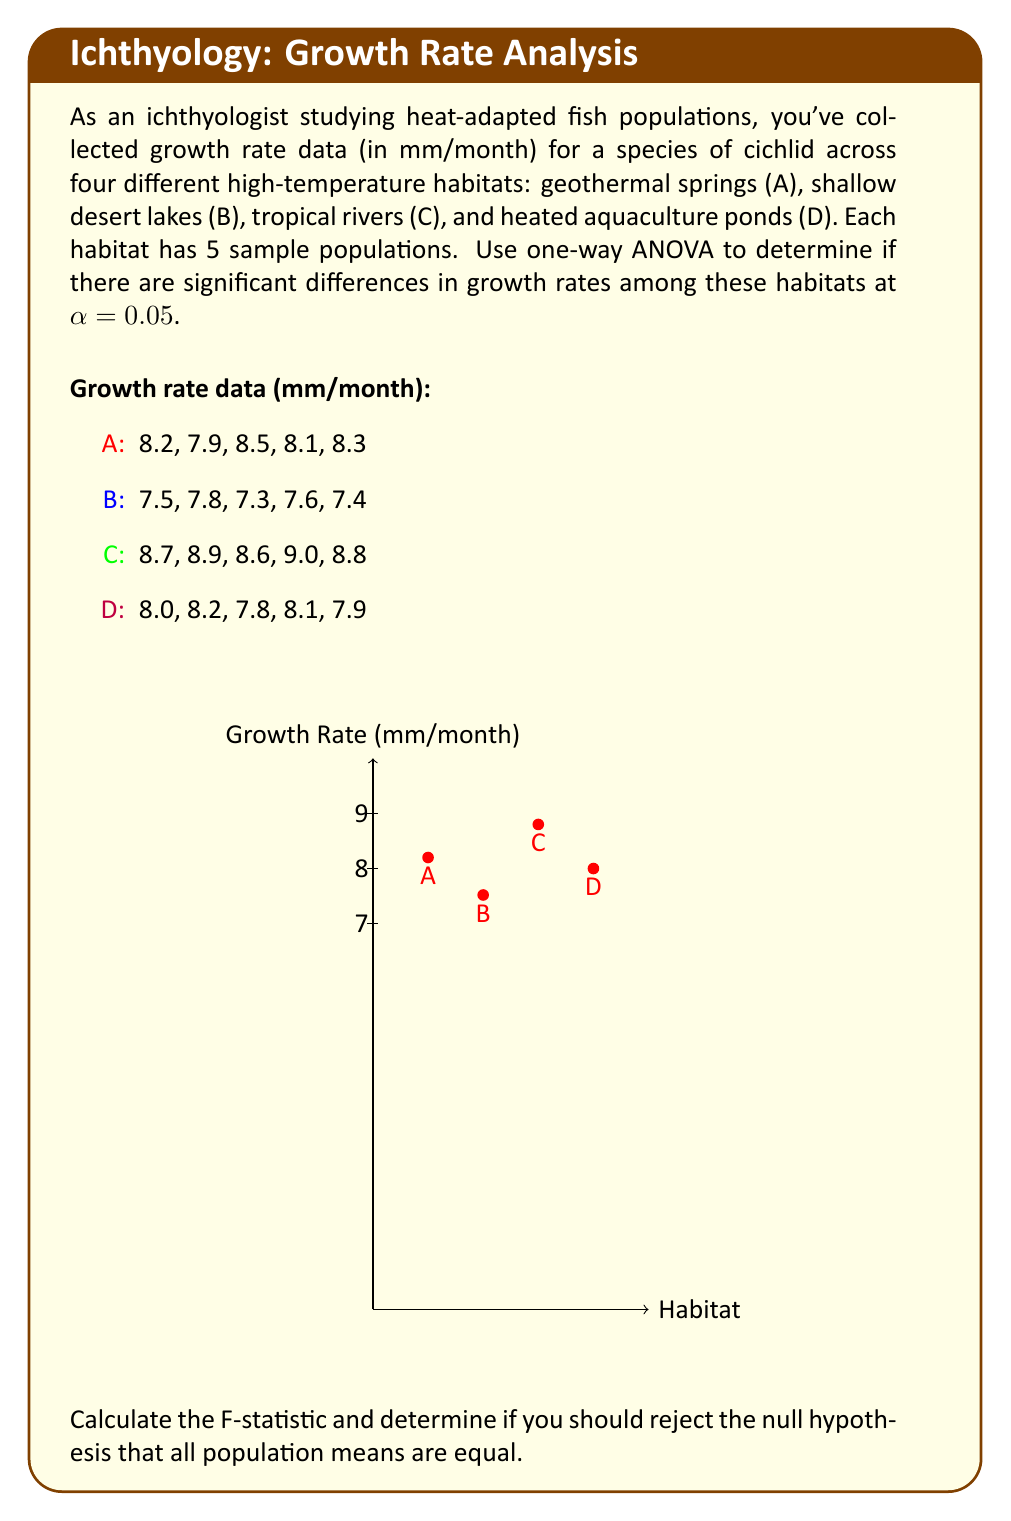Help me with this question. Let's solve this step-by-step using one-way ANOVA:

1) First, calculate the overall mean and group means:
   Overall mean = $\frac{(8.2+7.9+...+7.9)}{20} = 8.13$
   $\bar{A} = 8.2$, $\bar{B} = 7.52$, $\bar{C} = 8.8$, $\bar{D} = 8.0$

2) Calculate the Sum of Squares Total (SST):
   $$SST = \sum_{i=1}^{4}\sum_{j=1}^{5}(x_{ij} - \bar{x})^2 = 4.686$$

3) Calculate the Sum of Squares Between (SSB):
   $$SSB = 5\sum_{i=1}^{4}(\bar{x_i} - \bar{x})^2 = 4.1126$$

4) Calculate the Sum of Squares Within (SSW):
   $$SSW = SST - SSB = 4.686 - 4.1126 = 0.5734$$

5) Calculate degrees of freedom:
   df(between) = 4 - 1 = 3
   df(within) = 20 - 4 = 16
   df(total) = 20 - 1 = 19

6) Calculate Mean Square Between (MSB) and Mean Square Within (MSW):
   $$MSB = \frac{SSB}{df_{between}} = \frac{4.1126}{3} = 1.3709$$
   $$MSW = \frac{SSW}{df_{within}} = \frac{0.5734}{16} = 0.0358$$

7) Calculate the F-statistic:
   $$F = \frac{MSB}{MSW} = \frac{1.3709}{0.0358} = 38.29$$

8) Find the critical F-value:
   For α = 0.05, df(between) = 3, df(within) = 16
   F-critical = 3.24 (from F-distribution table)

9) Compare F-statistic to F-critical:
   38.29 > 3.24, so we reject the null hypothesis.
Answer: Reject null hypothesis; F(3,16) = 38.29, p < 0.05 